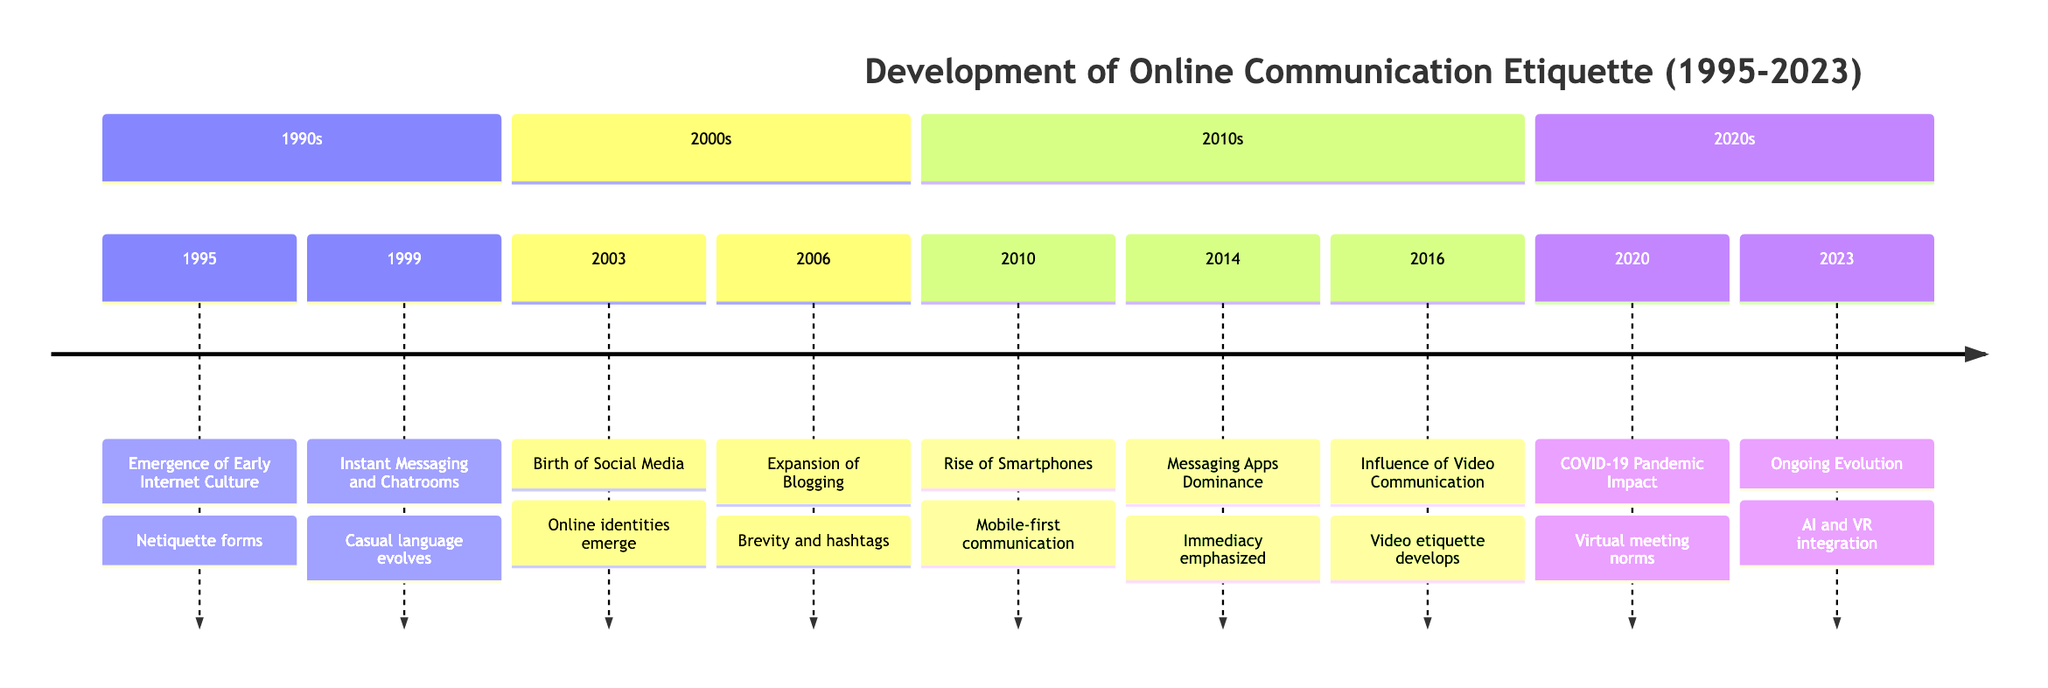What year did the emergence of early internet culture occur? The diagram indicates that the event "Emergence of Early Internet Culture" happened in the year 1995.
Answer: 1995 What event is associated with the year 2010? According to the timeline, the event listed for the year 2010 is "Rise of Smartphones."
Answer: Rise of Smartphones How many main sections are in the timeline? The timeline is divided into four sections: 1990s, 2000s, 2010s, and 2020s, which totals four sections.
Answer: 4 What was the impact of instant messaging and chatrooms according to the timeline? The impact of the event listed in 1999 states that it led to "Development of more casual and abbreviative language."
Answer: Development of more casual and abbreviative language Which year marks the introduction of widespread video communication? The diagram specifies that the influence of video communication began in the year 2016, as indicated under that section.
Answer: 2016 What were emerging guidelines associated with in 2023? The diagram mentions that in 2023, the guidelines are related to "interactions in virtual spaces and with AI."
Answer: Interactions in virtual spaces and with AI How did the COVID-19 pandemic affect online etiquette according to the diagram? The timeline notes that the pandemic led to "New norms for virtual meetings," highlighting how etiquette evolved during this period.
Answer: New norms for virtual meetings What impact did the rise of smartphones have on communication? According to the timeline, the rise of smartphones led to "Mobile-first communication style emphasizing quick responses."
Answer: Mobile-first communication style emphasizing quick responses What two events occurred in the 2000s, and what is their impact? In the 2000s, the events "Birth of Social Media" and "Expansion of Blogging" are noted, with impacts on online identities and brevity with hashtags.
Answer: Online identities emerge and Brevity and hashtags 